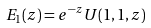<formula> <loc_0><loc_0><loc_500><loc_500>E _ { 1 } ( z ) = e ^ { - z } U ( 1 , 1 , z )</formula> 